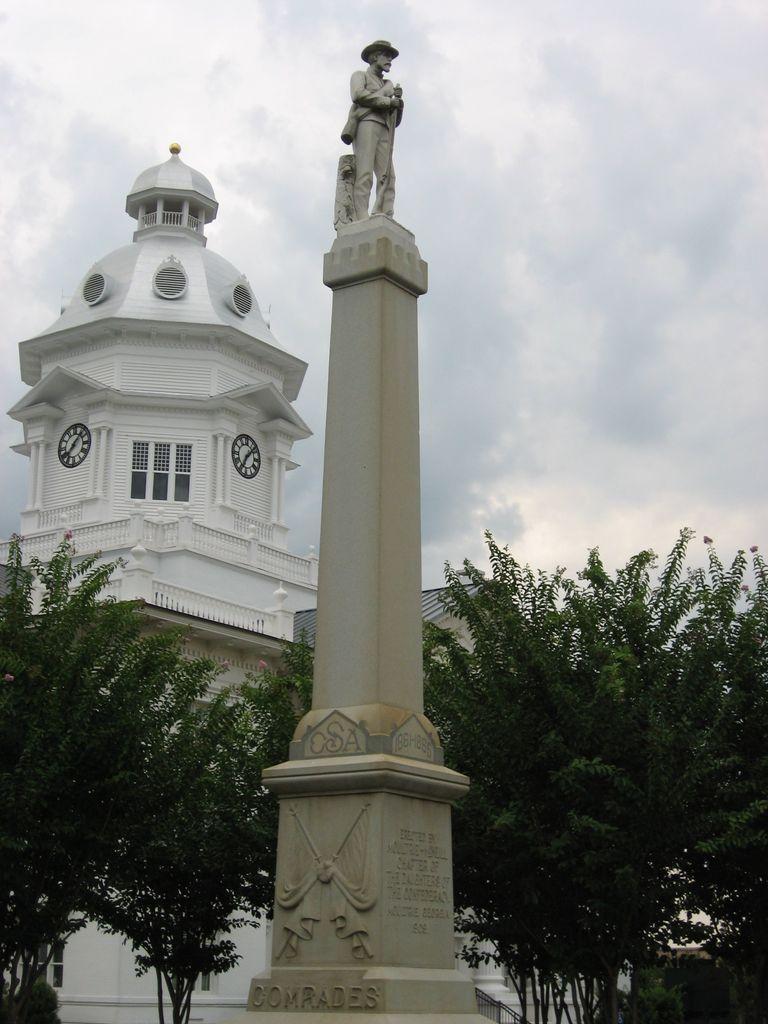Describe this image in one or two sentences. In this picture we can see the sky, building, windows, roof top. We can see the clocks on the walls. We can see the trees. On a tall pedestal we can see the statue of a man and some information. 